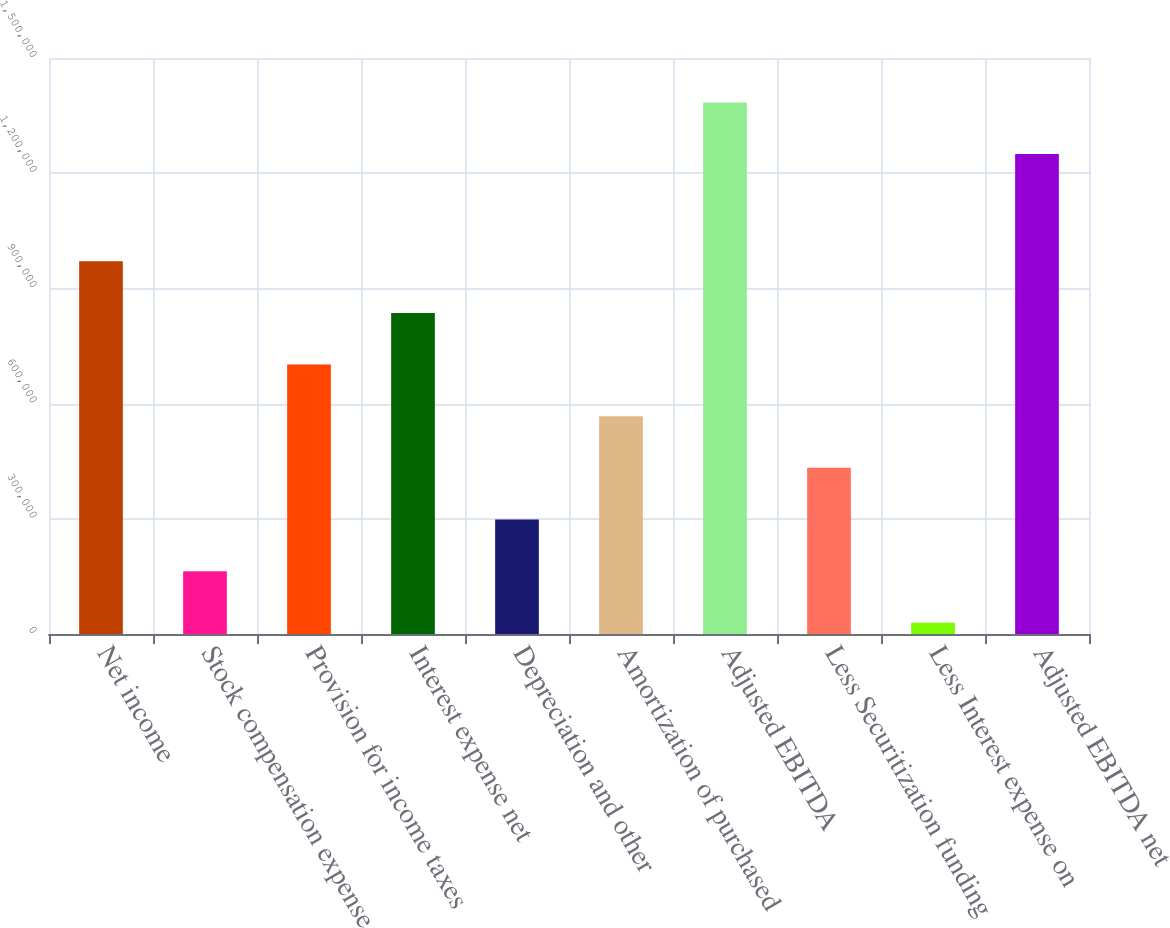Convert chart. <chart><loc_0><loc_0><loc_500><loc_500><bar_chart><fcel>Net income<fcel>Stock compensation expense<fcel>Provision for income taxes<fcel>Interest expense net<fcel>Depreciation and other<fcel>Amortization of purchased<fcel>Adjusted EBITDA<fcel>Less Securitization funding<fcel>Less Interest expense on<fcel>Adjusted EBITDA net<nl><fcel>970683<fcel>163621<fcel>701662<fcel>836173<fcel>298132<fcel>567152<fcel>1.38429e+06<fcel>432642<fcel>29111<fcel>1.24978e+06<nl></chart> 